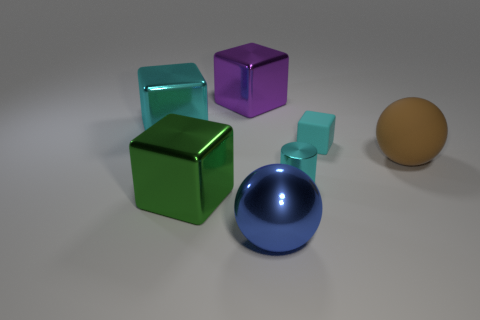Subtract all yellow cubes. Subtract all yellow cylinders. How many cubes are left? 4 Add 1 tiny cyan rubber blocks. How many objects exist? 8 Subtract all balls. How many objects are left? 5 Subtract 1 green blocks. How many objects are left? 6 Subtract all small cyan rubber balls. Subtract all big brown matte balls. How many objects are left? 6 Add 5 metallic balls. How many metallic balls are left? 6 Add 4 big yellow cylinders. How many big yellow cylinders exist? 4 